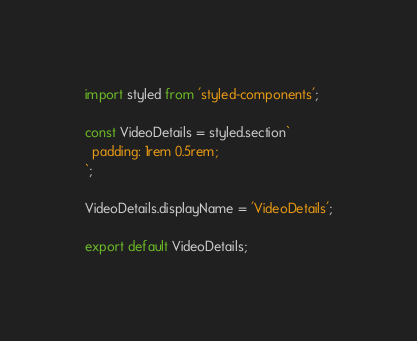Convert code to text. <code><loc_0><loc_0><loc_500><loc_500><_JavaScript_>import styled from 'styled-components';

const VideoDetails = styled.section`
  padding: 1rem 0.5rem;
`;

VideoDetails.displayName = 'VideoDetails';

export default VideoDetails;
</code> 